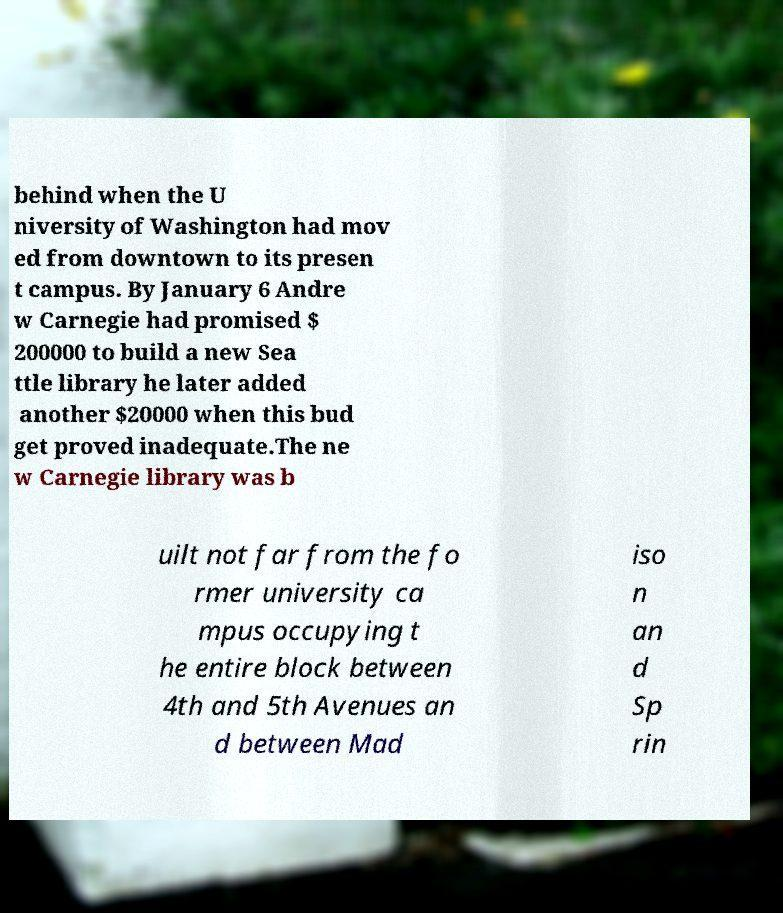I need the written content from this picture converted into text. Can you do that? behind when the U niversity of Washington had mov ed from downtown to its presen t campus. By January 6 Andre w Carnegie had promised $ 200000 to build a new Sea ttle library he later added another $20000 when this bud get proved inadequate.The ne w Carnegie library was b uilt not far from the fo rmer university ca mpus occupying t he entire block between 4th and 5th Avenues an d between Mad iso n an d Sp rin 